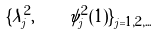Convert formula to latex. <formula><loc_0><loc_0><loc_500><loc_500>\{ \lambda _ { j } ^ { 2 } , \quad \psi _ { j } ^ { 2 } ( 1 ) \} _ { j = 1 , 2 , \dots }</formula> 